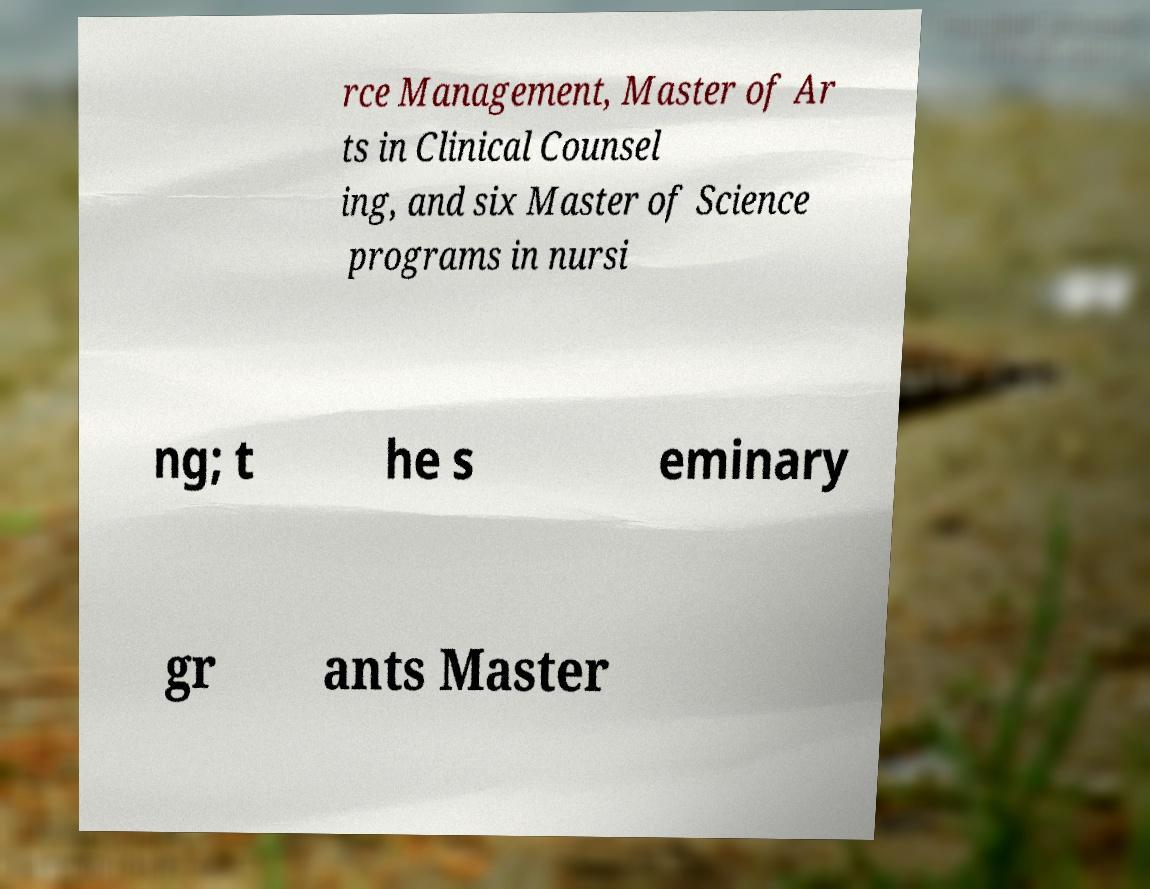Can you accurately transcribe the text from the provided image for me? rce Management, Master of Ar ts in Clinical Counsel ing, and six Master of Science programs in nursi ng; t he s eminary gr ants Master 